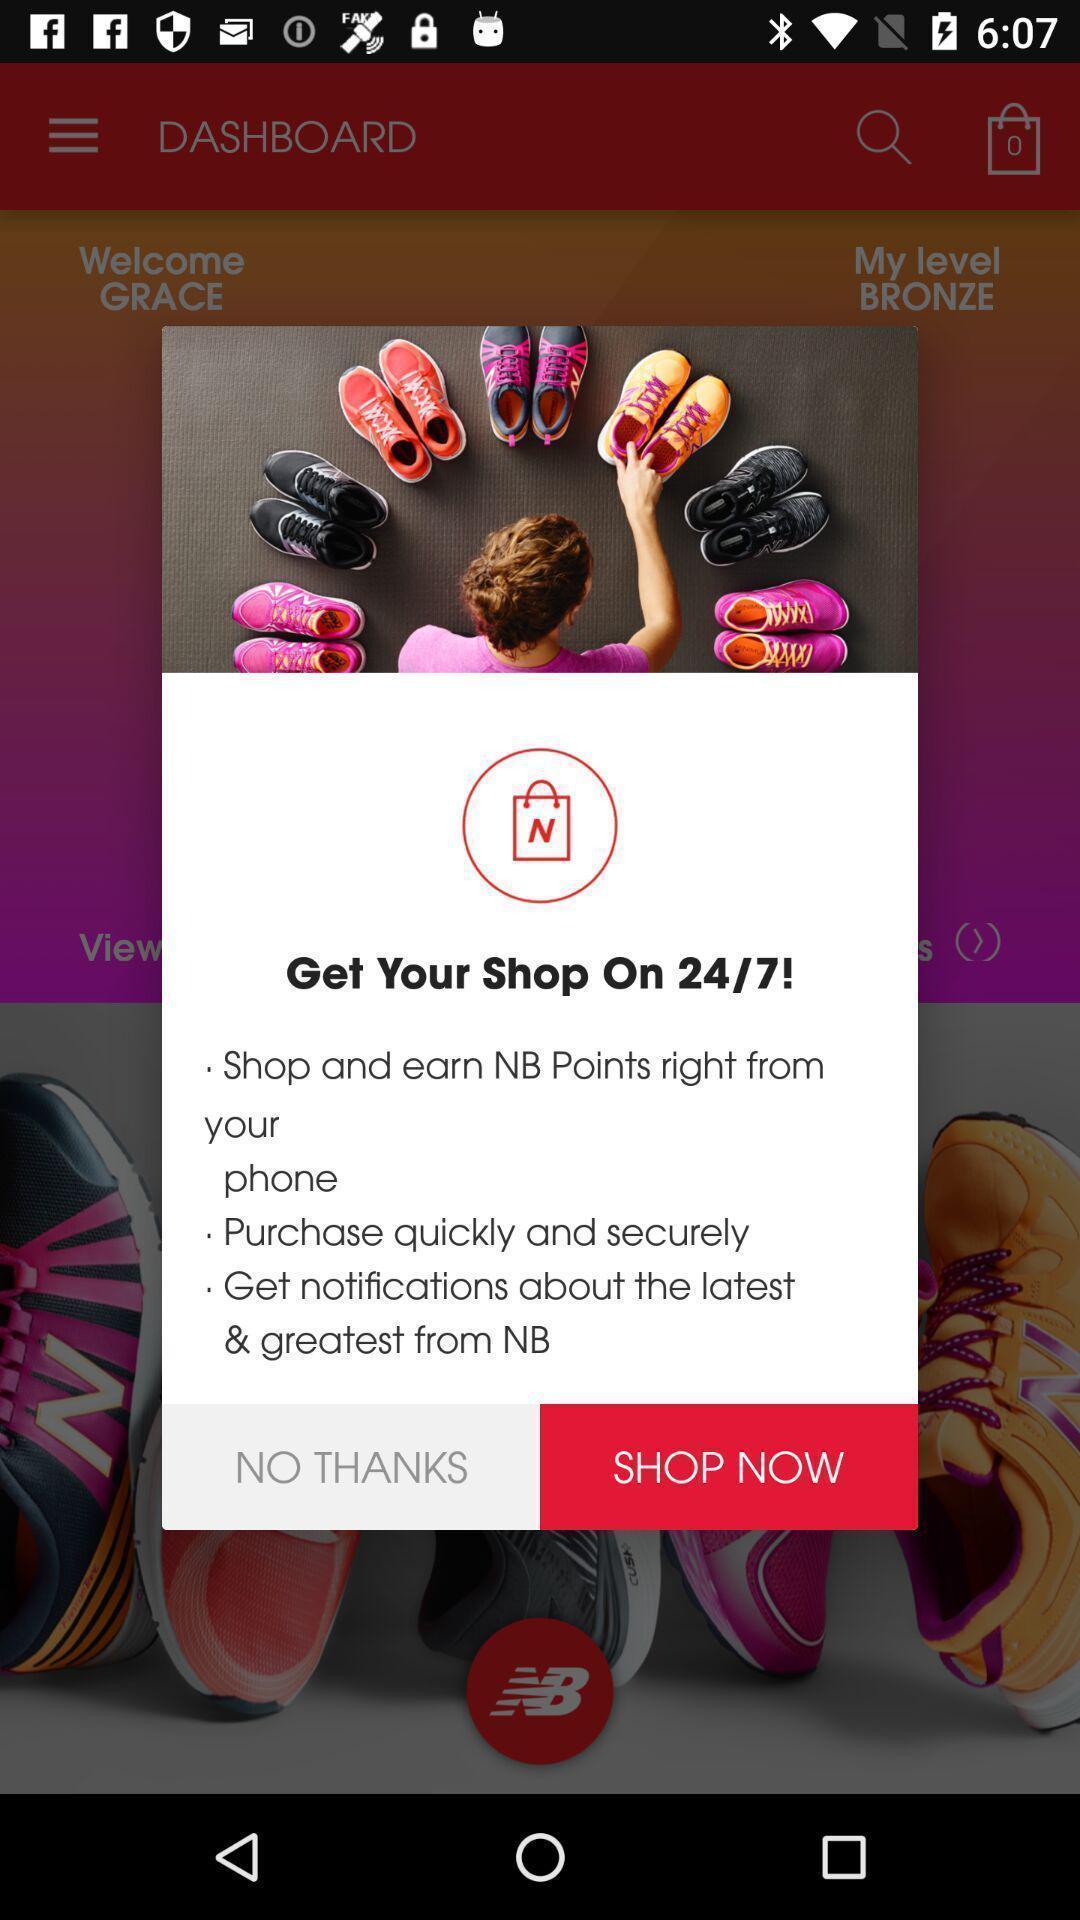Provide a textual representation of this image. Pop-up with options in a shopping based app. 